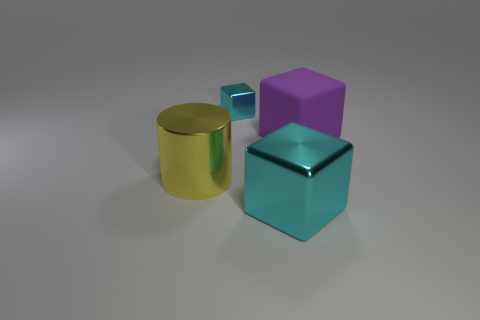Subtract all big purple blocks. How many blocks are left? 2 Subtract all red cylinders. How many cyan cubes are left? 2 Subtract 1 cubes. How many cubes are left? 2 Add 3 tiny red cubes. How many objects exist? 7 Subtract all cubes. How many objects are left? 1 Subtract all brown rubber balls. Subtract all small cyan shiny objects. How many objects are left? 3 Add 3 matte cubes. How many matte cubes are left? 4 Add 1 red metal balls. How many red metal balls exist? 1 Subtract 0 cyan cylinders. How many objects are left? 4 